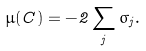<formula> <loc_0><loc_0><loc_500><loc_500>\mu ( C ) = - 2 \sum _ { j } \sigma _ { j } .</formula> 